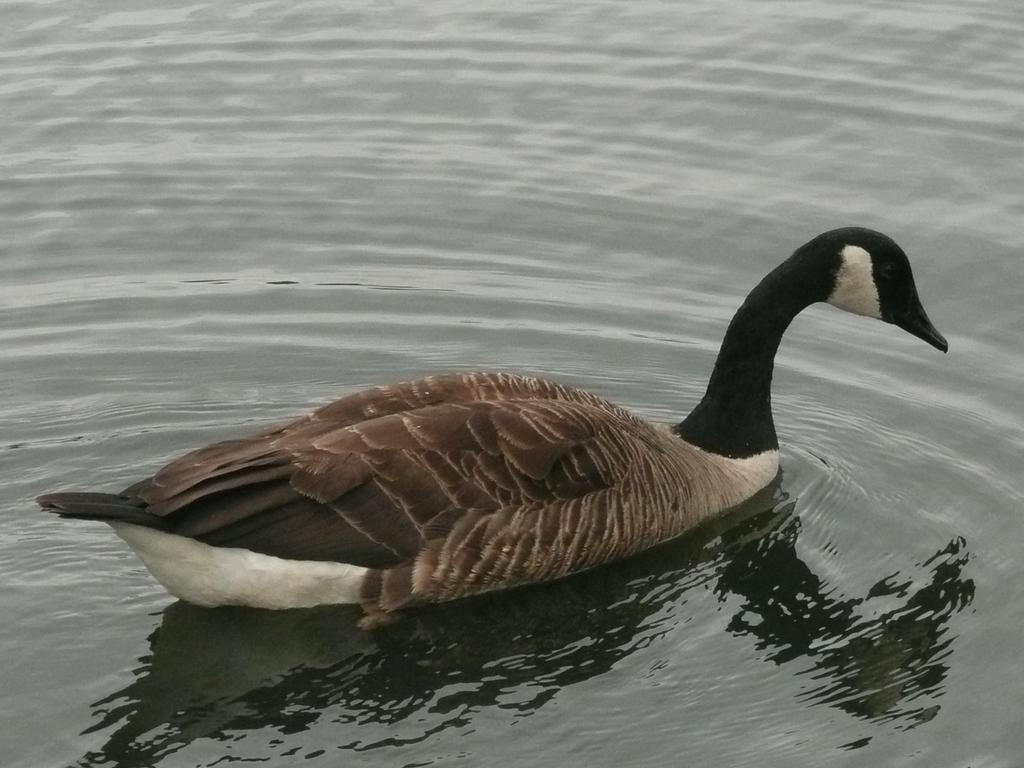What animal can be seen in the image? There is a duck in the image. What is the duck doing in the image? The duck is swimming in the water. Where might the duck be swimming? The water might be in a pond. What colors can be seen on the duck's feathers? The duck has brown, black, and white coloring. What part of the quince tree is visible in the image? There is no quince tree present in the image; it features a duck swimming in water. 